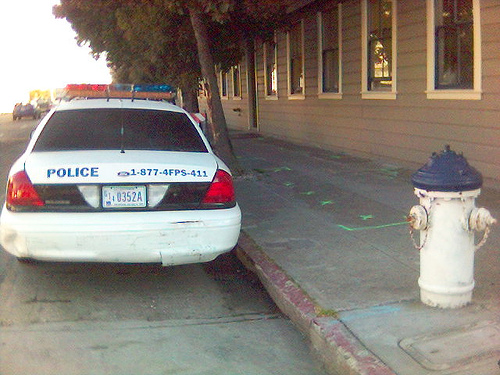Read and extract the text from this image. 1 877 4FPS -411 POLICE 0352A 